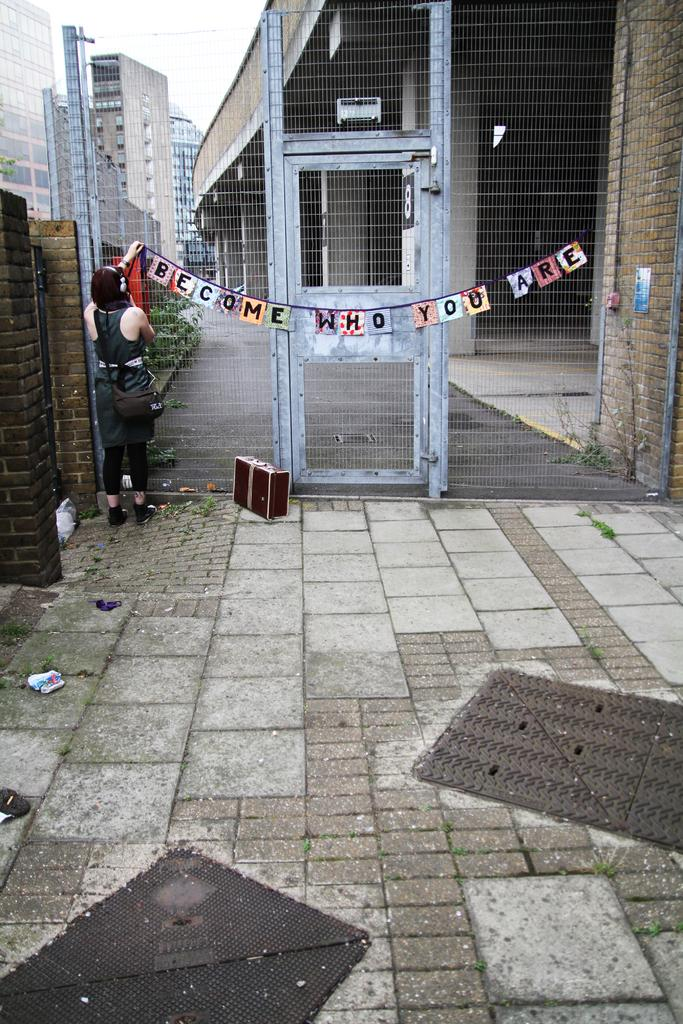Provide a one-sentence caption for the provided image. A locked high gate with a banner proclaiming 'Become who you are' draped across its door. 